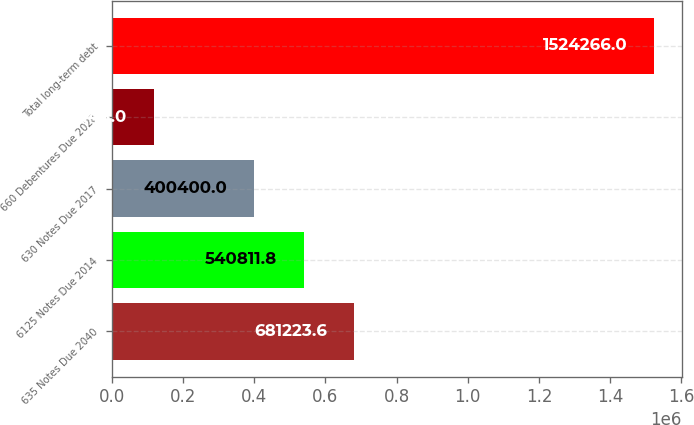Convert chart. <chart><loc_0><loc_0><loc_500><loc_500><bar_chart><fcel>635 Notes Due 2040<fcel>6125 Notes Due 2014<fcel>630 Notes Due 2017<fcel>660 Debentures Due 2028<fcel>Total long-term debt<nl><fcel>681224<fcel>540812<fcel>400400<fcel>120148<fcel>1.52427e+06<nl></chart> 